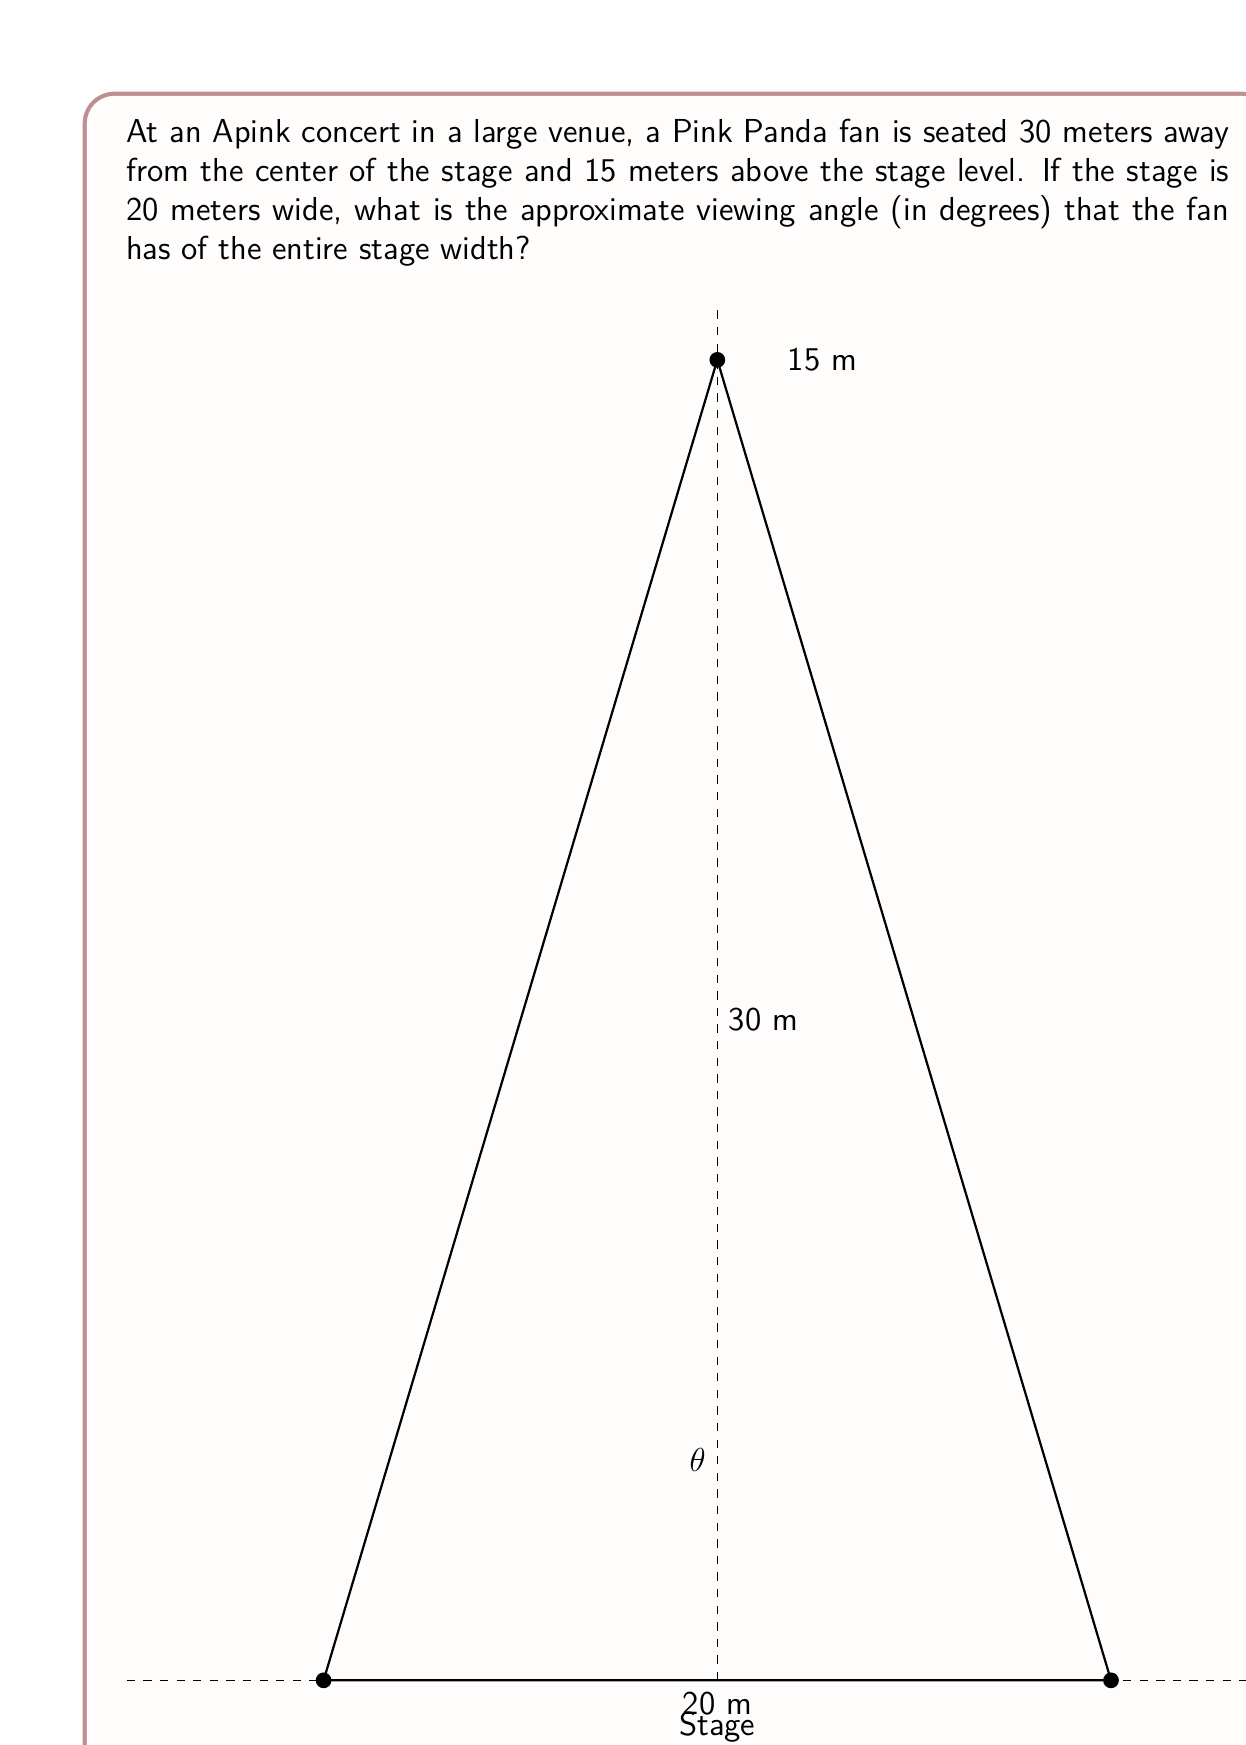Show me your answer to this math problem. Let's approach this step-by-step:

1) First, we need to understand what we're calculating. The viewing angle is the angle formed by the lines from the fan's eyes to the left and right edges of the stage.

2) We can treat this as a right triangle problem. The fan's position forms the apex of an isosceles triangle, with the stage width as the base.

3) We know:
   - The stage width is 20 meters
   - The fan is 30 meters away from the center of the stage
   - The fan is 15 meters above the stage level

4) We need to find the distance from the fan to the center of the stage in a straight line. We can use the Pythagorean theorem:

   $$d = \sqrt{30^2 + 15^2} = \sqrt{1125} \approx 33.54 \text{ meters}$$

5) Now, we have a right triangle where:
   - The hypotenuse is 33.54 meters
   - Half of the stage width (10 meters) forms one side

6) We can use the tangent function to find half of our viewing angle:

   $$\tan(\frac{\theta}{2}) = \frac{10}{33.54}$$

7) Solving for $\theta$:

   $$\frac{\theta}{2} = \arctan(\frac{10}{33.54})$$
   $$\theta = 2 \cdot \arctan(\frac{10}{33.54})$$

8) Calculating this:

   $$\theta = 2 \cdot \arctan(0.2981) \approx 33.40 \text{ degrees}$$

Therefore, the approximate viewing angle for the Apink fan is about 33.40 degrees.
Answer: The approximate viewing angle is 33.40 degrees. 